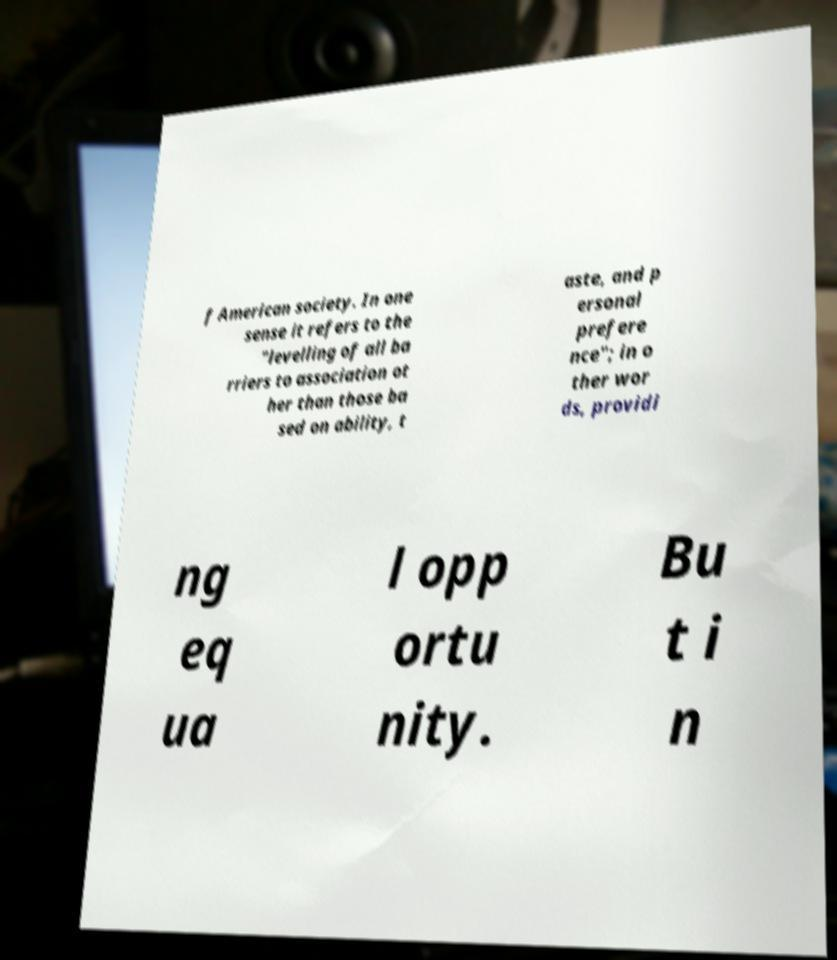Could you assist in decoding the text presented in this image and type it out clearly? f American society. In one sense it refers to the "levelling of all ba rriers to association ot her than those ba sed on ability, t aste, and p ersonal prefere nce"; in o ther wor ds, providi ng eq ua l opp ortu nity. Bu t i n 